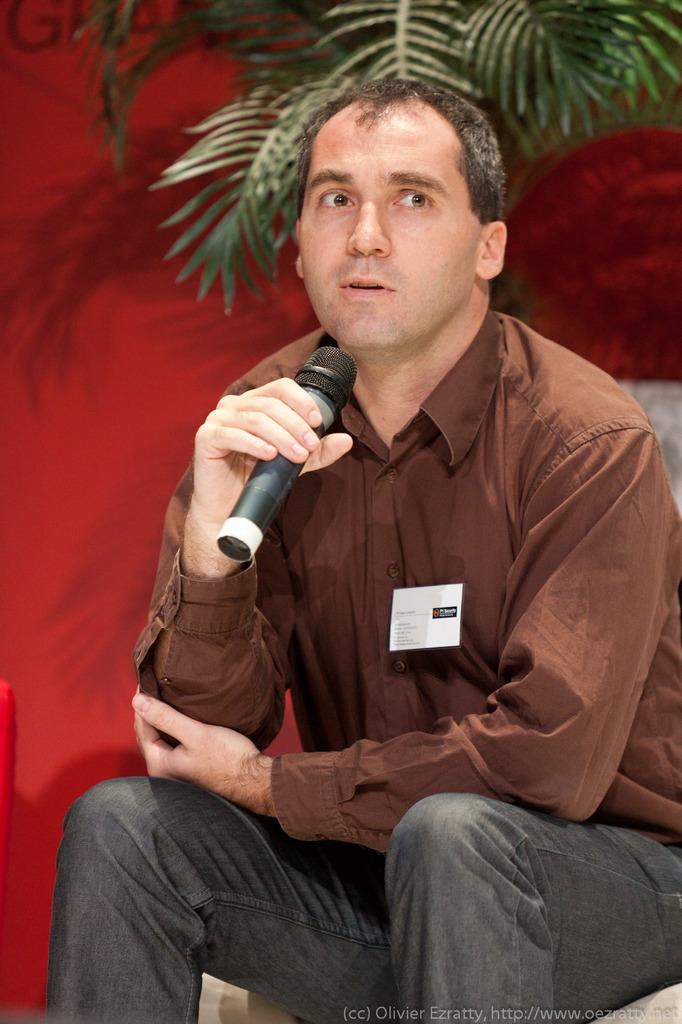What is the main subject of the image? There is a man in the image. What is the man doing in the image? The man is sitting. What is the man holding in the image? The man is holding a mic. What can be seen in the background of the image? There is a plant in the background of the image. What color is the wall in the background? The wall in the background is red colored. Can you see a crow perched on the plant in the background? There is no crow present in the image; only a man, a mic, a plant, and a red-colored wall are visible. 